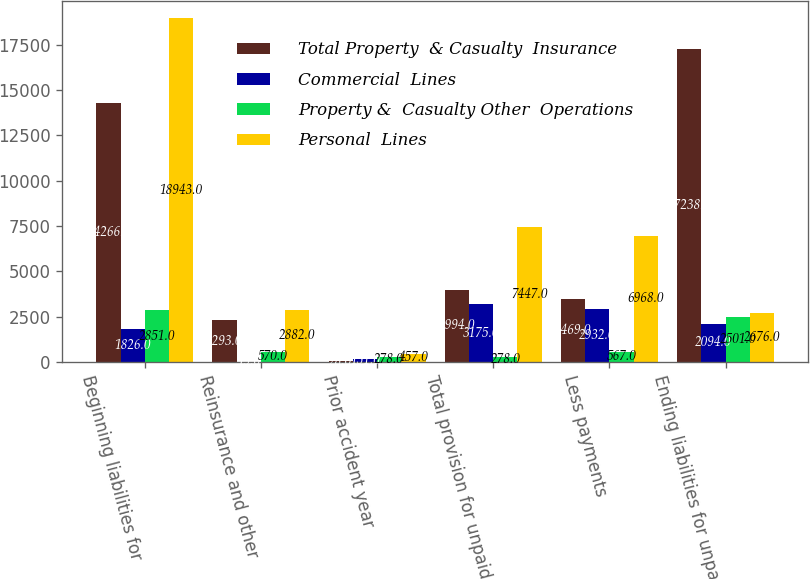<chart> <loc_0><loc_0><loc_500><loc_500><stacked_bar_chart><ecel><fcel>Beginning liabilities for<fcel>Reinsurance and other<fcel>Prior accident year<fcel>Total provision for unpaid<fcel>Less payments<fcel>Ending liabilities for unpaid<nl><fcel>Total Property  & Casualty  Insurance<fcel>14266<fcel>2293<fcel>28<fcel>3994<fcel>3469<fcel>17238<nl><fcel>Commercial  Lines<fcel>1826<fcel>19<fcel>151<fcel>3175<fcel>2932<fcel>2094<nl><fcel>Property &  Casualty Other  Operations<fcel>2851<fcel>570<fcel>278<fcel>278<fcel>567<fcel>2501<nl><fcel>Personal  Lines<fcel>18943<fcel>2882<fcel>457<fcel>7447<fcel>6968<fcel>2676<nl></chart> 